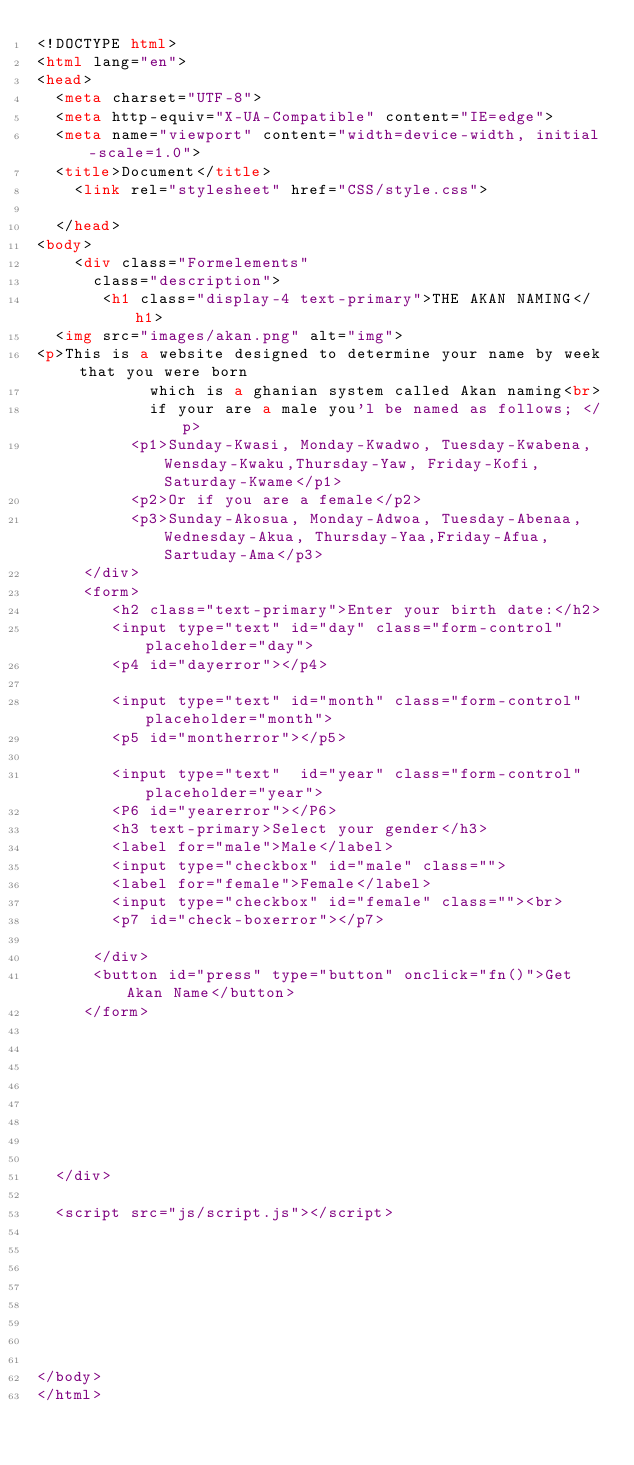Convert code to text. <code><loc_0><loc_0><loc_500><loc_500><_HTML_><!DOCTYPE html>
<html lang="en">
<head>
  <meta charset="UTF-8">
  <meta http-equiv="X-UA-Compatible" content="IE=edge">
  <meta name="viewport" content="width=device-width, initial-scale=1.0">
  <title>Document</title>
    <link rel="stylesheet" href="CSS/style.css">
    
  </head>
<body> 
    <div class="Formelements"
      class="description">
       <h1 class="display-4 text-primary">THE AKAN NAMING</h1>
  <img src="images/akan.png" alt="img">
<p>This is a website designed to determine your name by week that you were born
            which is a ghanian system called Akan naming<br>
            if your are a male you'l be named as follows; </p>
          <p1>Sunday-Kwasi, Monday-Kwadwo, Tuesday-Kwabena, Wensday-Kwaku,Thursday-Yaw, Friday-Kofi, Saturday-Kwame</p1>
          <p2>Or if you are a female</p2>
          <p3>Sunday-Akosua, Monday-Adwoa, Tuesday-Abenaa, Wednesday-Akua, Thursday-Yaa,Friday-Afua,Sartuday-Ama</p3>
     </div>
     <form>
        <h2 class="text-primary">Enter your birth date:</h2>
        <input type="text" id="day" class="form-control" placeholder="day">
        <p4 id="dayerror"></p4>

        <input type="text" id="month" class="form-control" placeholder="month">
        <p5 id="montherror"></p5>

        <input type="text"  id="year" class="form-control" placeholder="year">
        <P6 id="yearerror"></P6>
        <h3 text-primary>Select your gender</h3>
        <label for="male">Male</label>
        <input type="checkbox" id="male" class="">
        <label for="female">Female</label>
        <input type="checkbox" id="female" class=""><br>
        <p7 id="check-boxerror"></p7>

      </div>  
      <button id="press" type="button" onclick="fn()">Get Akan Name</button>
     </form>  

    
         
  
  
  
  
  
  </div>
  
  <script src="js/script.js"></script>

  
  
  


  

</body>
</html></code> 